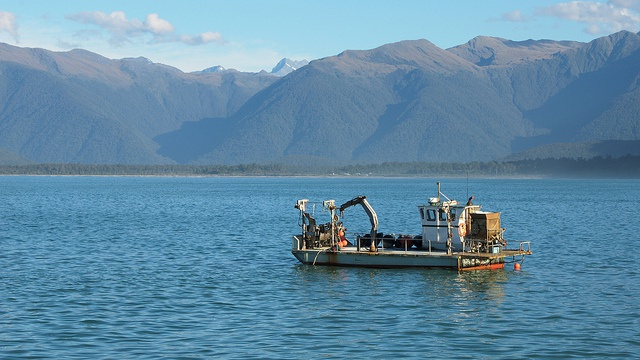Describe the objects in this image and their specific colors. I can see a boat in lightblue, black, blue, and gray tones in this image. 